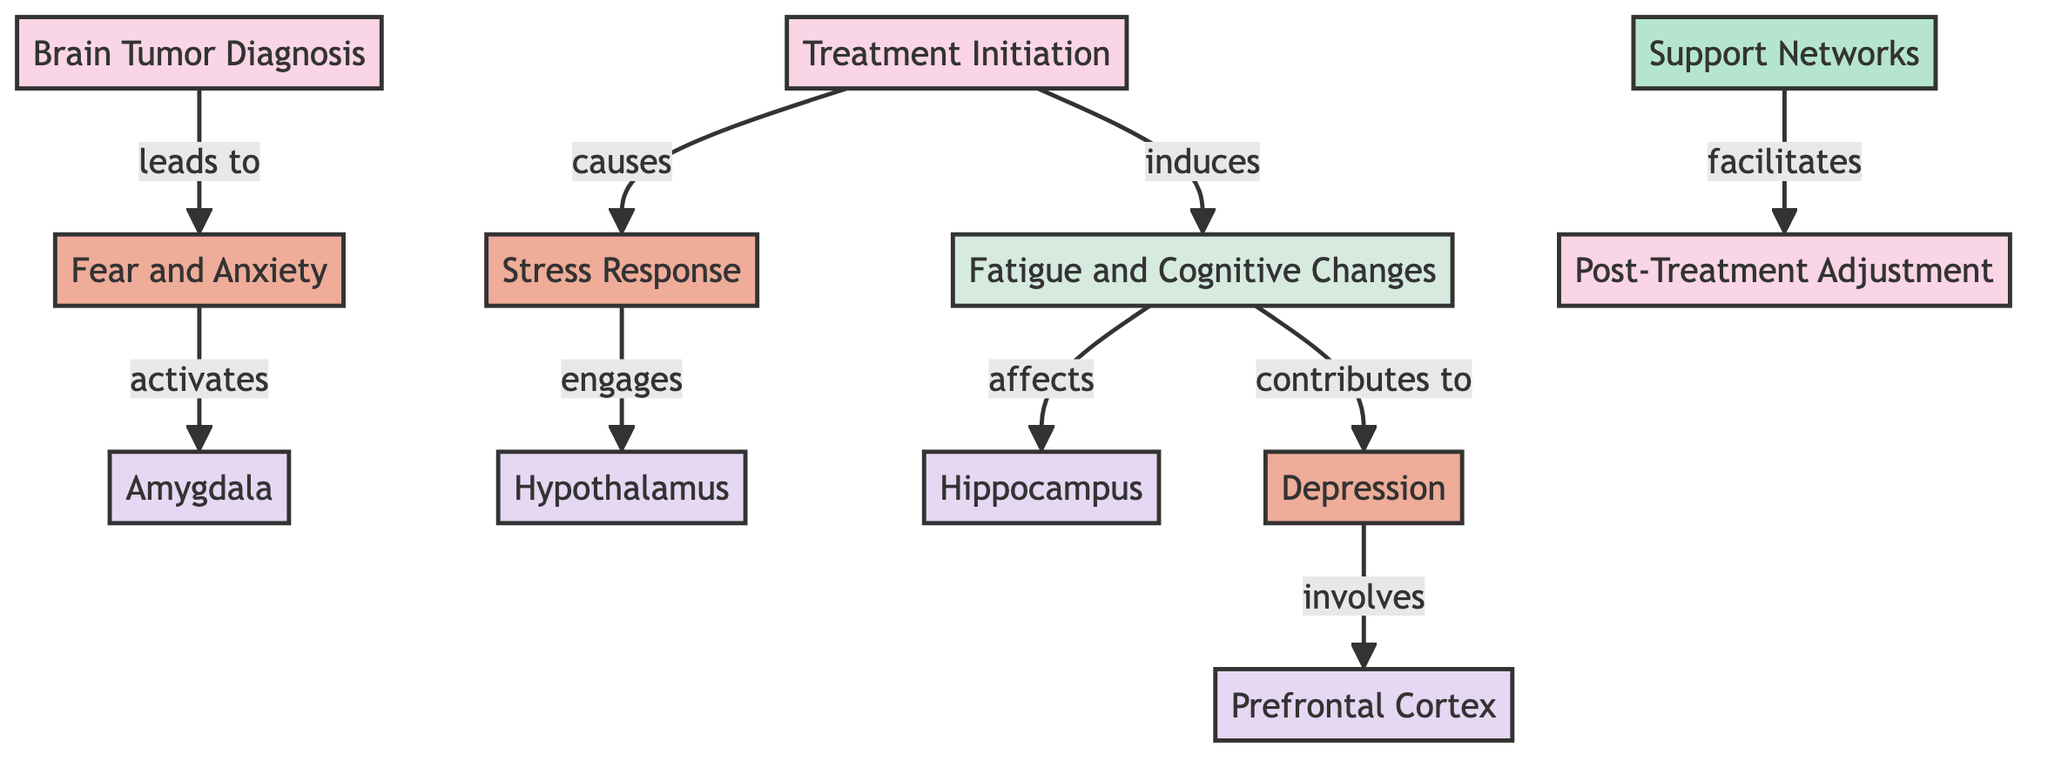What is the first event in the diagram? The first event in the diagram, as indicated by the top node, is "Brain Tumor Diagnosis." This is the starting point for the flow of emotional and psychological impacts depicted.
Answer: Brain Tumor Diagnosis How many emotional states are illustrated in the diagram? The diagram depicts four emotional states: "Fear and Anxiety," "Stress Response," "Depression," and "Support Networks." Counting these emotional nodes gives us a total of four.
Answer: Four Which brain region is associated with "Fear and Anxiety"? The brain region linked to "Fear and Anxiety" is "Amygdala" as shown in the diagram. It indicates the neurological connection to this emotional state.
Answer: Amygdala Which events lead to "Post-Treatment Adjustment"? "Post-Treatment Adjustment" is facilitated by "Support Networks," which is linked to the various emotional states and reactions experienced during treatment.
Answer: Support Networks What impact does "Fatigue and Cognitive Changes" have on brain function? "Fatigue and Cognitive Changes" affects the "Hippocampus," which suggests its role in how these symptoms may influence memory and emotion processing.
Answer: Hippocampus If treatment leads to stress response, which brain region is engaged? The stress response following treatment activates the "Hypothalamus," indicating the brain's regulatory response to stress during treatment.
Answer: Hypothalamus What emotional state involves the "Prefrontal Cortex"? "Depression" involves the "Prefrontal Cortex," highlighting the cognitive and emotional engagement during the experience of depression.
Answer: Depression What do "Fear and Anxiety" activate? "Fear and Anxiety" activate the "Amygdala," emphasizing its role in processing these specific emotional responses to the diagnosis.
Answer: Amygdala 